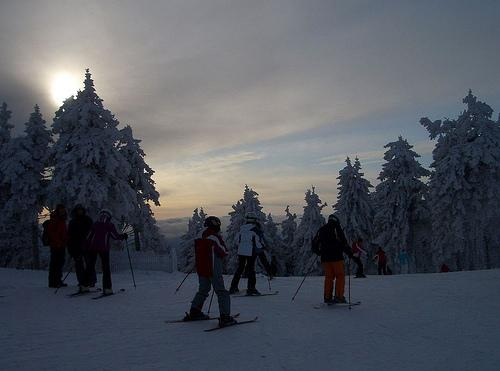What is touching the snow? Please explain your reasoning. skis. A group of people are on skis and are standing in a snowy area. 